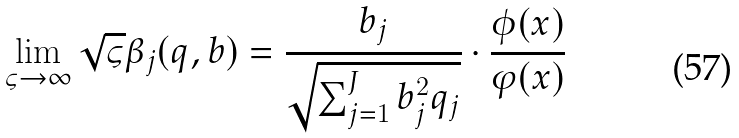<formula> <loc_0><loc_0><loc_500><loc_500>\lim _ { \varsigma \to \infty } \sqrt { \varsigma } \beta _ { j } ( q , b ) = \frac { b _ { j } } { { \sqrt { \sum \nolimits _ { j = 1 } ^ { J } { b _ { j } ^ { 2 } { q _ { j } } } } } } \cdot \frac { \phi ( x ) } { \varphi ( x ) }</formula> 